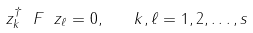Convert formula to latex. <formula><loc_0><loc_0><loc_500><loc_500>\ z _ { k } ^ { \dagger } \ F \ z _ { \ell } = 0 , \quad k , \ell = 1 , 2 , \dots , s</formula> 